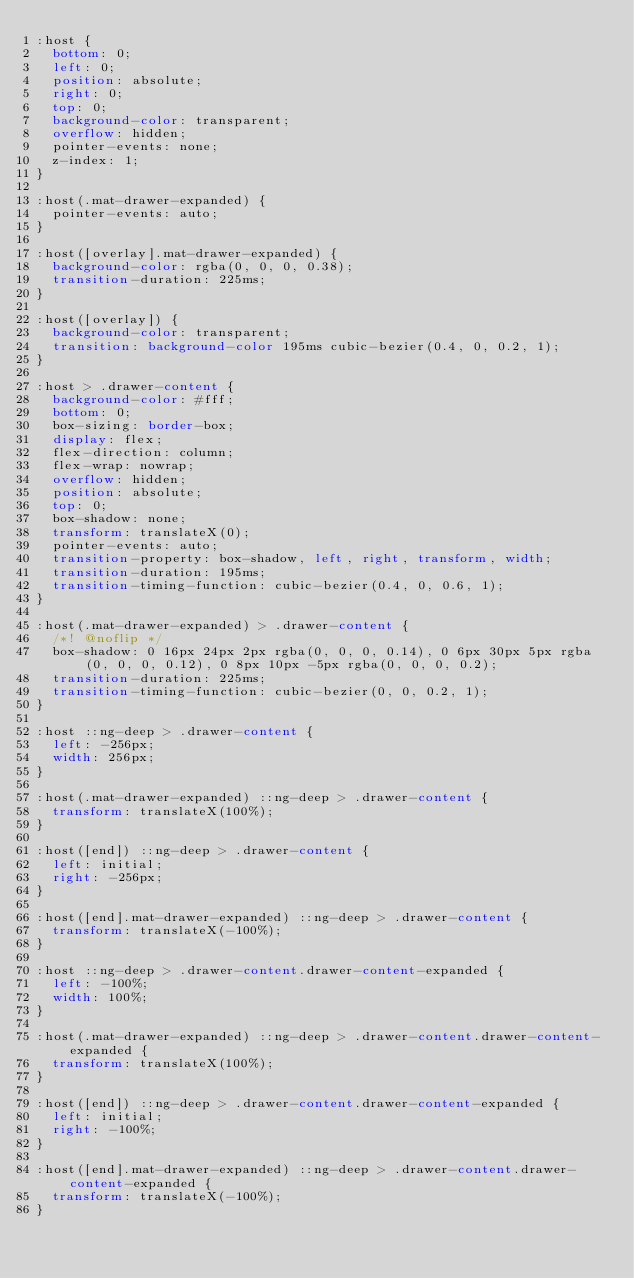Convert code to text. <code><loc_0><loc_0><loc_500><loc_500><_CSS_>:host {
  bottom: 0;
  left: 0;
  position: absolute;
  right: 0;
  top: 0;
  background-color: transparent;
  overflow: hidden;
  pointer-events: none;
  z-index: 1;
}

:host(.mat-drawer-expanded) {
  pointer-events: auto;
}

:host([overlay].mat-drawer-expanded) {
  background-color: rgba(0, 0, 0, 0.38);
  transition-duration: 225ms;
}

:host([overlay]) {
  background-color: transparent;
  transition: background-color 195ms cubic-bezier(0.4, 0, 0.2, 1);
}

:host > .drawer-content {
  background-color: #fff;
  bottom: 0;
  box-sizing: border-box;
  display: flex;
  flex-direction: column;
  flex-wrap: nowrap;
  overflow: hidden;
  position: absolute;
  top: 0;
  box-shadow: none;
  transform: translateX(0);
  pointer-events: auto;
  transition-property: box-shadow, left, right, transform, width;
  transition-duration: 195ms;
  transition-timing-function: cubic-bezier(0.4, 0, 0.6, 1);
}

:host(.mat-drawer-expanded) > .drawer-content {
  /*! @noflip */
  box-shadow: 0 16px 24px 2px rgba(0, 0, 0, 0.14), 0 6px 30px 5px rgba(0, 0, 0, 0.12), 0 8px 10px -5px rgba(0, 0, 0, 0.2);
  transition-duration: 225ms;
  transition-timing-function: cubic-bezier(0, 0, 0.2, 1);
}

:host ::ng-deep > .drawer-content {
  left: -256px;
  width: 256px;
}

:host(.mat-drawer-expanded) ::ng-deep > .drawer-content {
  transform: translateX(100%);
}

:host([end]) ::ng-deep > .drawer-content {
  left: initial;
  right: -256px;
}

:host([end].mat-drawer-expanded) ::ng-deep > .drawer-content {
  transform: translateX(-100%);
}

:host ::ng-deep > .drawer-content.drawer-content-expanded {
  left: -100%;
  width: 100%;
}

:host(.mat-drawer-expanded) ::ng-deep > .drawer-content.drawer-content-expanded {
  transform: translateX(100%);
}

:host([end]) ::ng-deep > .drawer-content.drawer-content-expanded {
  left: initial;
  right: -100%;
}

:host([end].mat-drawer-expanded) ::ng-deep > .drawer-content.drawer-content-expanded {
  transform: translateX(-100%);
}
</code> 